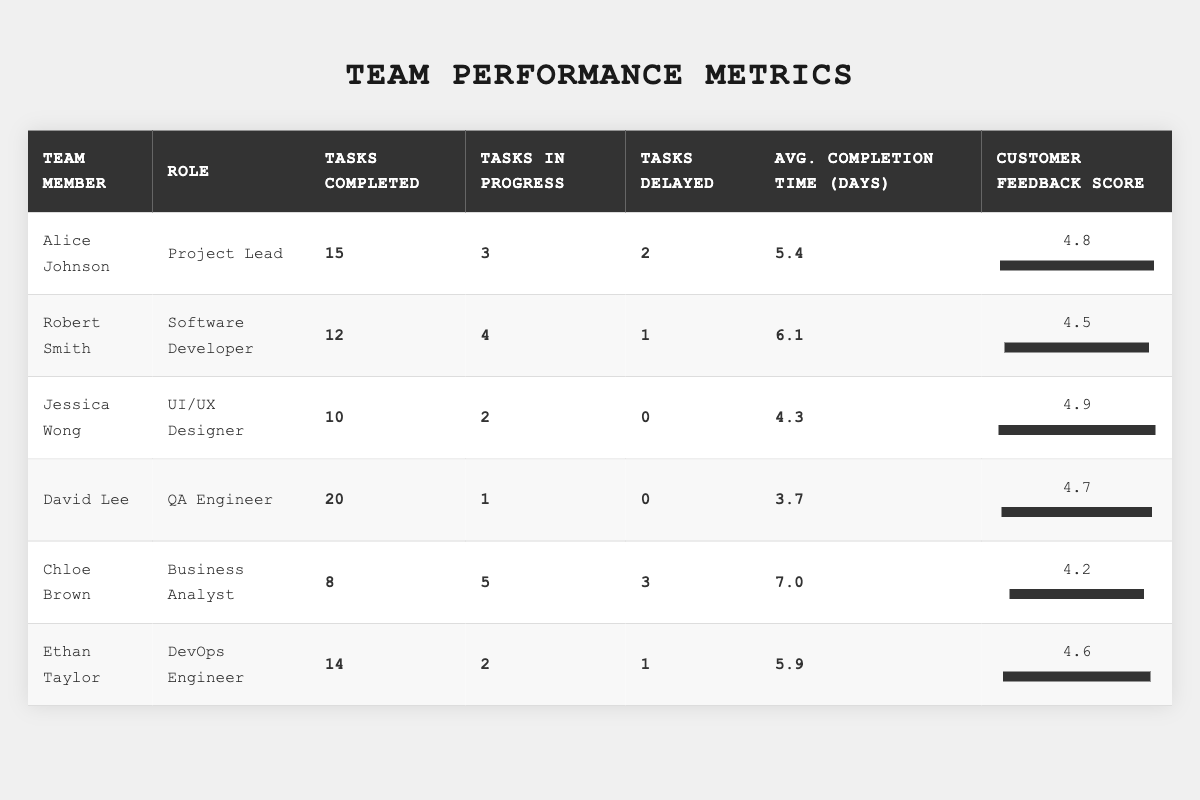What is the role of Alice Johnson? From the table, under the "Role" column, Alice Johnson is classified as the "Project Lead."
Answer: Project Lead How many tasks did David Lee complete? The table shows that David Lee completed 20 tasks, referenced in the "Tasks Completed" column.
Answer: 20 What is the customer feedback score for Jessica Wong? The table indicates that Jessica Wong received a customer feedback score of 4.9, found under the "Customer Feedback Score" column.
Answer: 4.9 Who completed the least number of tasks? By examining the "Tasks Completed" column, Chloe Brown completed the least tasks, totaling 8.
Answer: Chloe Brown What is the average task completion time for the team? To find the average, sum the average task completion times (5.4 + 6.1 + 4.3 + 3.7 + 7.0 + 5.9) = 32.4, and divide by the number of team members (6). So, 32.4 / 6 = 5.4 days.
Answer: 5.4 days Is there anyone who has not delayed any tasks? From the "Tasks Delayed" column, both Jessica Wong and David Lee have a delay count of 0, confirming that they did not delay any tasks.
Answer: Yes What is the difference in customer feedback score between the best and worst performers? The highest score is Jessica Wong (4.9) and the lowest is Chloe Brown (4.2). The difference is 4.9 - 4.2 = 0.7.
Answer: 0.7 Who has the highest average task completion time? Looking at the "Avg. Completion Time (Days)" column, Chloe Brown has the highest average at 7.0 days, compared to all other members.
Answer: Chloe Brown If we sum the tasks in progress for the entire team, what is the total? By adding up the "Tasks in Progress" values (3 + 4 + 2 + 1 + 5 + 2) = 17.
Answer: 17 Does every team member have a customer feedback score of at least 4.0? By reviewing the scores, all members have scores above 4.0: Alice (4.8), Robert (4.5), Jessica (4.9), David (4.7), Chloe (4.2), and Ethan (4.6).
Answer: Yes 